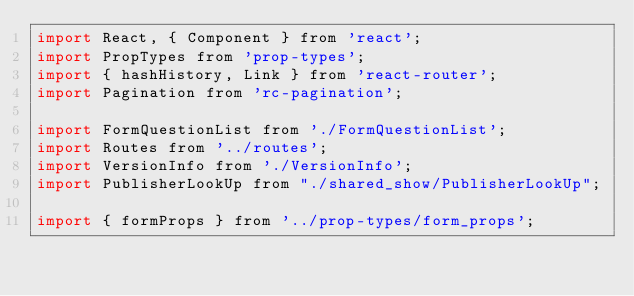Convert code to text. <code><loc_0><loc_0><loc_500><loc_500><_JavaScript_>import React, { Component } from 'react';
import PropTypes from 'prop-types';
import { hashHistory, Link } from 'react-router';
import Pagination from 'rc-pagination';

import FormQuestionList from './FormQuestionList';
import Routes from '../routes';
import VersionInfo from './VersionInfo';
import PublisherLookUp from "./shared_show/PublisherLookUp";

import { formProps } from '../prop-types/form_props';</code> 